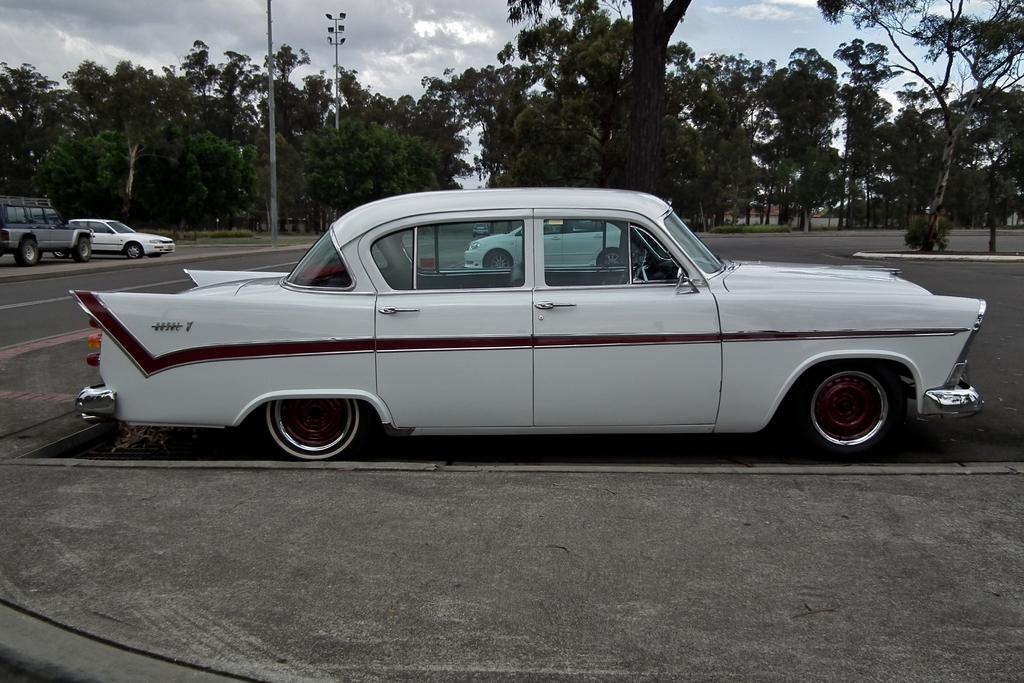What color is the car in the image? The car in the image is white. Where is the car located in the image? The car is parked on the road. What can be seen on the left side of the image? There are cars on the left side of the image. What type of vegetation is visible at the back side of the image? There are trees at the back side of the image. What is the condition of the sky in the image? The sky is cloudy in the image. Is there an amusement park visible in the image? No, there is no amusement park present in the image. Can you tell me how many people are swimming in the image? There is no swimming or pool visible in the image. 